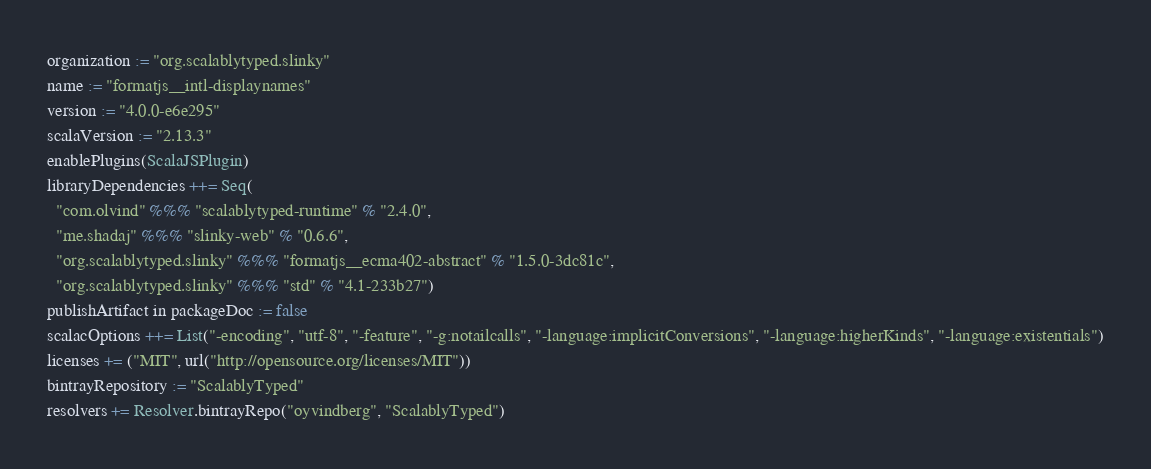Convert code to text. <code><loc_0><loc_0><loc_500><loc_500><_Scala_>organization := "org.scalablytyped.slinky"
name := "formatjs__intl-displaynames"
version := "4.0.0-e6e295"
scalaVersion := "2.13.3"
enablePlugins(ScalaJSPlugin)
libraryDependencies ++= Seq(
  "com.olvind" %%% "scalablytyped-runtime" % "2.4.0",
  "me.shadaj" %%% "slinky-web" % "0.6.6",
  "org.scalablytyped.slinky" %%% "formatjs__ecma402-abstract" % "1.5.0-3dc81c",
  "org.scalablytyped.slinky" %%% "std" % "4.1-233b27")
publishArtifact in packageDoc := false
scalacOptions ++= List("-encoding", "utf-8", "-feature", "-g:notailcalls", "-language:implicitConversions", "-language:higherKinds", "-language:existentials")
licenses += ("MIT", url("http://opensource.org/licenses/MIT"))
bintrayRepository := "ScalablyTyped"
resolvers += Resolver.bintrayRepo("oyvindberg", "ScalablyTyped")
</code> 